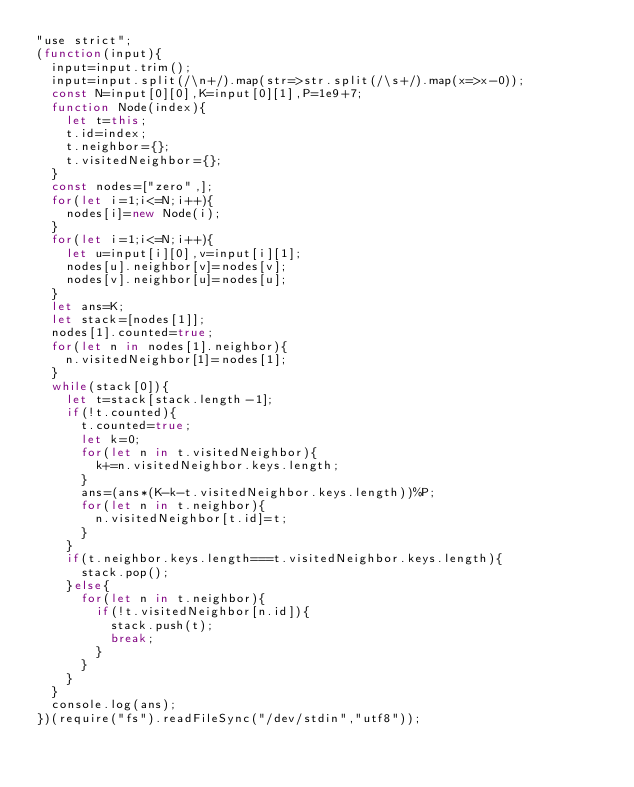Convert code to text. <code><loc_0><loc_0><loc_500><loc_500><_JavaScript_>"use strict";
(function(input){
  input=input.trim();
  input=input.split(/\n+/).map(str=>str.split(/\s+/).map(x=>x-0));
  const N=input[0][0],K=input[0][1],P=1e9+7;
  function Node(index){
    let t=this;
    t.id=index;
    t.neighbor={};
    t.visitedNeighbor={};
  }
  const nodes=["zero",];
  for(let i=1;i<=N;i++){
    nodes[i]=new Node(i);
  }
  for(let i=1;i<=N;i++){
    let u=input[i][0],v=input[i][1];
    nodes[u].neighbor[v]=nodes[v];
    nodes[v].neighbor[u]=nodes[u];
  }
  let ans=K;
  let stack=[nodes[1]];
  nodes[1].counted=true;
  for(let n in nodes[1].neighbor){
    n.visitedNeighbor[1]=nodes[1];
  }
  while(stack[0]){
    let t=stack[stack.length-1];
    if(!t.counted){
      t.counted=true;
      let k=0;
      for(let n in t.visitedNeighbor){
        k+=n.visitedNeighbor.keys.length;
      }
      ans=(ans*(K-k-t.visitedNeighbor.keys.length))%P;
      for(let n in t.neighbor){
        n.visitedNeighbor[t.id]=t;
      }
    }
    if(t.neighbor.keys.length===t.visitedNeighbor.keys.length){
      stack.pop();
    }else{
      for(let n in t.neighbor){
        if(!t.visitedNeighbor[n.id]){
          stack.push(t);
          break;
        }
      }
    }
  }
  console.log(ans);
})(require("fs").readFileSync("/dev/stdin","utf8"));
</code> 